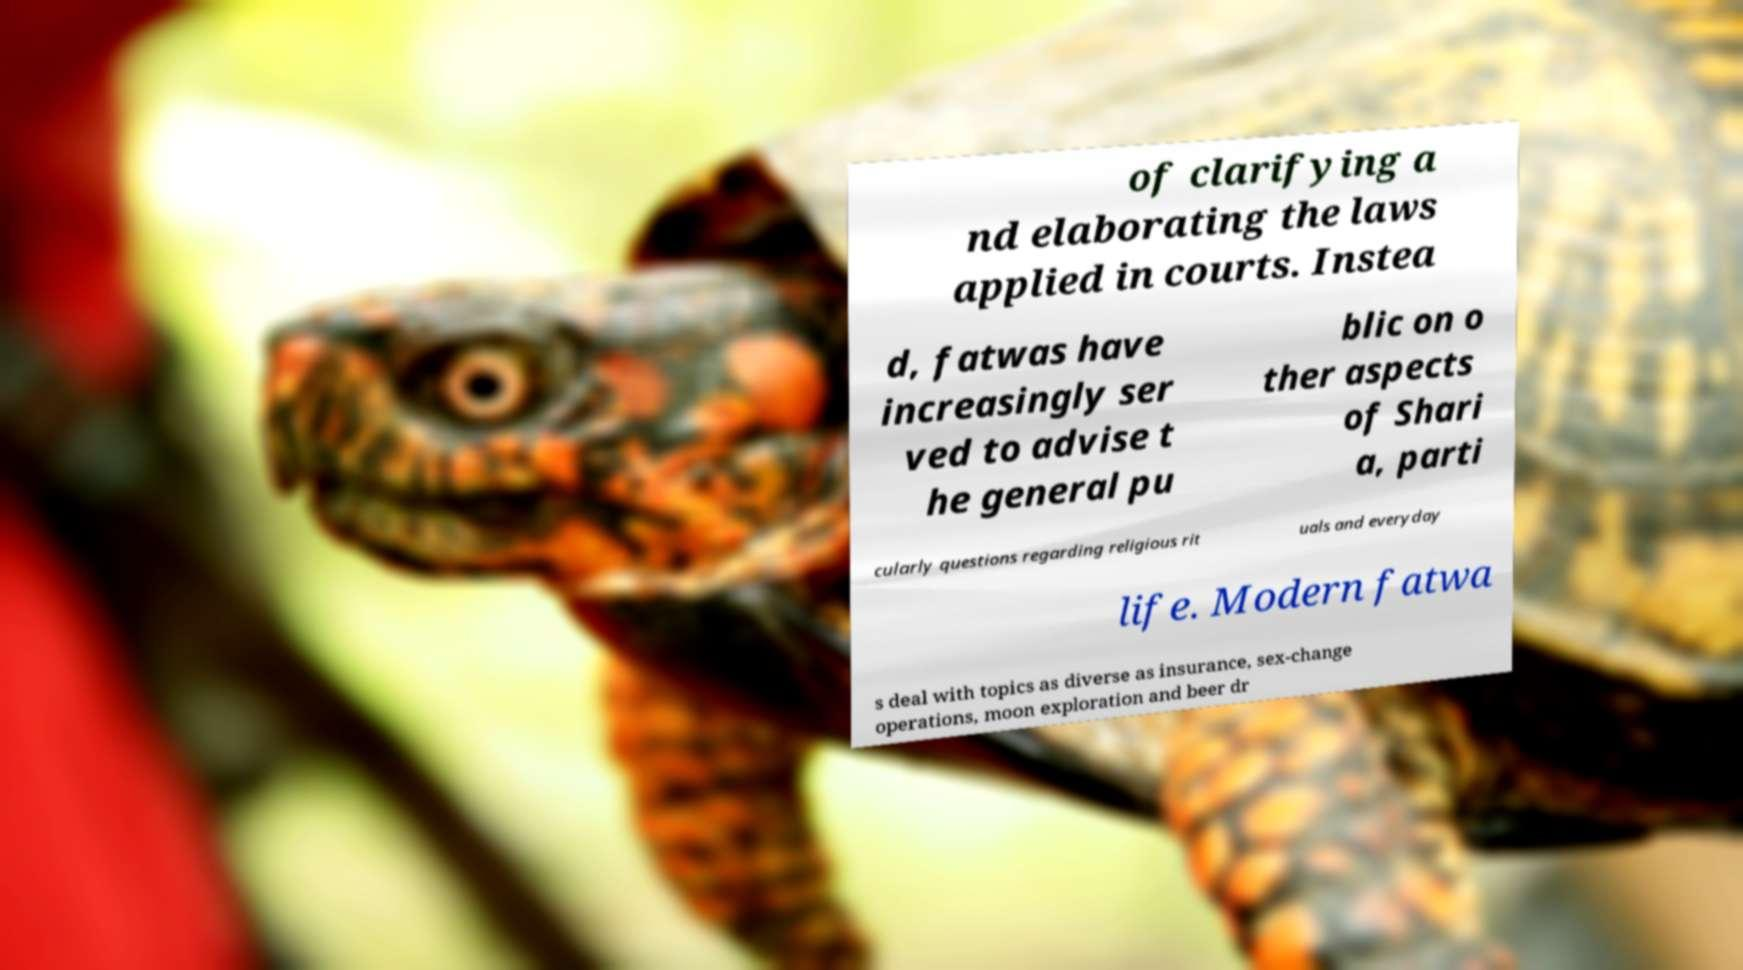I need the written content from this picture converted into text. Can you do that? of clarifying a nd elaborating the laws applied in courts. Instea d, fatwas have increasingly ser ved to advise t he general pu blic on o ther aspects of Shari a, parti cularly questions regarding religious rit uals and everyday life. Modern fatwa s deal with topics as diverse as insurance, sex-change operations, moon exploration and beer dr 